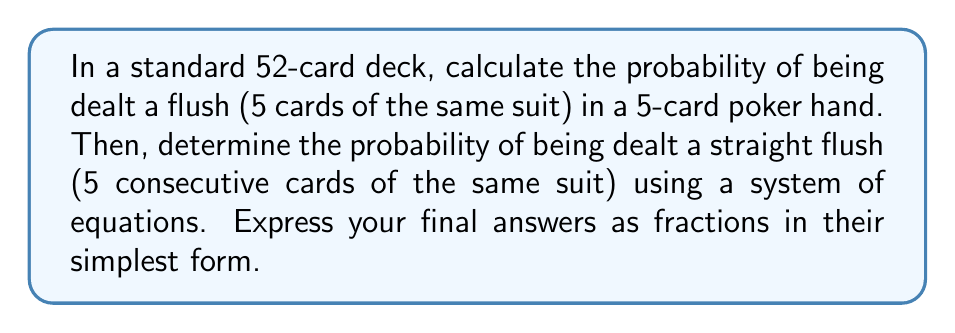Help me with this question. Let's approach this step-by-step using a system of equations:

1) First, let's define our variables:
   $F$ = probability of a flush
   $SF$ = probability of a straight flush

2) We know that the total number of 5-card hands is:
   $$\binom{52}{5} = 2,598,960$$

3) For a flush, we choose 1 of 4 suits, then any 5 cards from that suit:
   $$F = \frac{4 \cdot \binom{13}{5}}{\binom{52}{5}}$$

4) For a straight flush, we have 10 possible high cards (Ace can be high or low) in each of 4 suits:
   $$SF = \frac{40}{\binom{52}{5}}$$

5) Now, we can set up our system of equations:
   $$F = \frac{4 \cdot \binom{13}{5}}{\binom{52}{5}}$$
   $$SF = \frac{40}{\binom{52}{5}}$$

6) Solving for $F$:
   $$F = \frac{4 \cdot 1287}{2598960} = \frac{5148}{2598960} = \frac{33}{16660}$$

7) Solving for $SF$:
   $$SF = \frac{40}{2598960} = \frac{1}{64974}$$

These probabilities are crucial for a poker player to understand the likelihood of these rare and valuable hands.
Answer: Probability of a flush: $\frac{33}{16660}$
Probability of a straight flush: $\frac{1}{64974}$ 